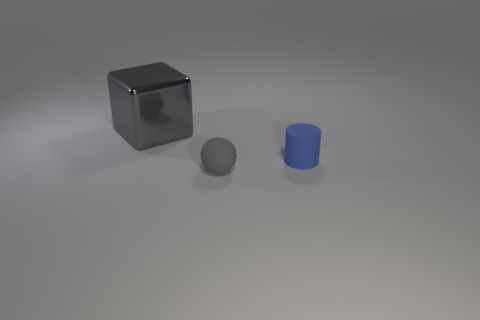What number of other objects are there of the same shape as the big gray object?
Your answer should be very brief. 0. Is there a object that has the same color as the small ball?
Offer a very short reply. Yes. Do the small blue matte thing and the rubber thing that is in front of the small blue rubber object have the same shape?
Offer a terse response. No. What number of other objects are there of the same size as the blue matte cylinder?
Your answer should be compact. 1. How big is the object behind the tiny cylinder?
Your response must be concise. Large. What number of things are the same material as the gray cube?
Provide a short and direct response. 0. Does the gray thing that is behind the tiny cylinder have the same shape as the blue matte thing?
Keep it short and to the point. No. There is a gray thing in front of the big gray metal thing; what is its shape?
Your answer should be compact. Sphere. What size is the rubber object that is the same color as the block?
Your answer should be very brief. Small. What is the small gray object made of?
Your response must be concise. Rubber. 